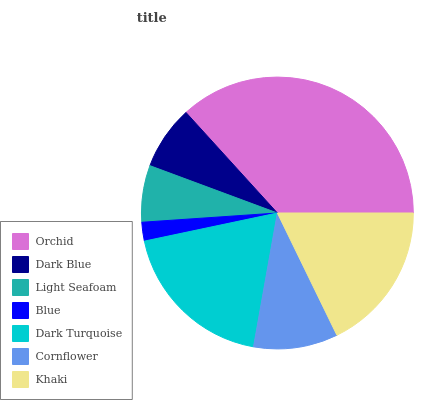Is Blue the minimum?
Answer yes or no. Yes. Is Orchid the maximum?
Answer yes or no. Yes. Is Dark Blue the minimum?
Answer yes or no. No. Is Dark Blue the maximum?
Answer yes or no. No. Is Orchid greater than Dark Blue?
Answer yes or no. Yes. Is Dark Blue less than Orchid?
Answer yes or no. Yes. Is Dark Blue greater than Orchid?
Answer yes or no. No. Is Orchid less than Dark Blue?
Answer yes or no. No. Is Cornflower the high median?
Answer yes or no. Yes. Is Cornflower the low median?
Answer yes or no. Yes. Is Light Seafoam the high median?
Answer yes or no. No. Is Light Seafoam the low median?
Answer yes or no. No. 